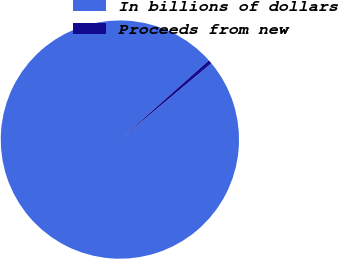Convert chart. <chart><loc_0><loc_0><loc_500><loc_500><pie_chart><fcel>In billions of dollars<fcel>Proceeds from new<nl><fcel>99.48%<fcel>0.52%<nl></chart> 